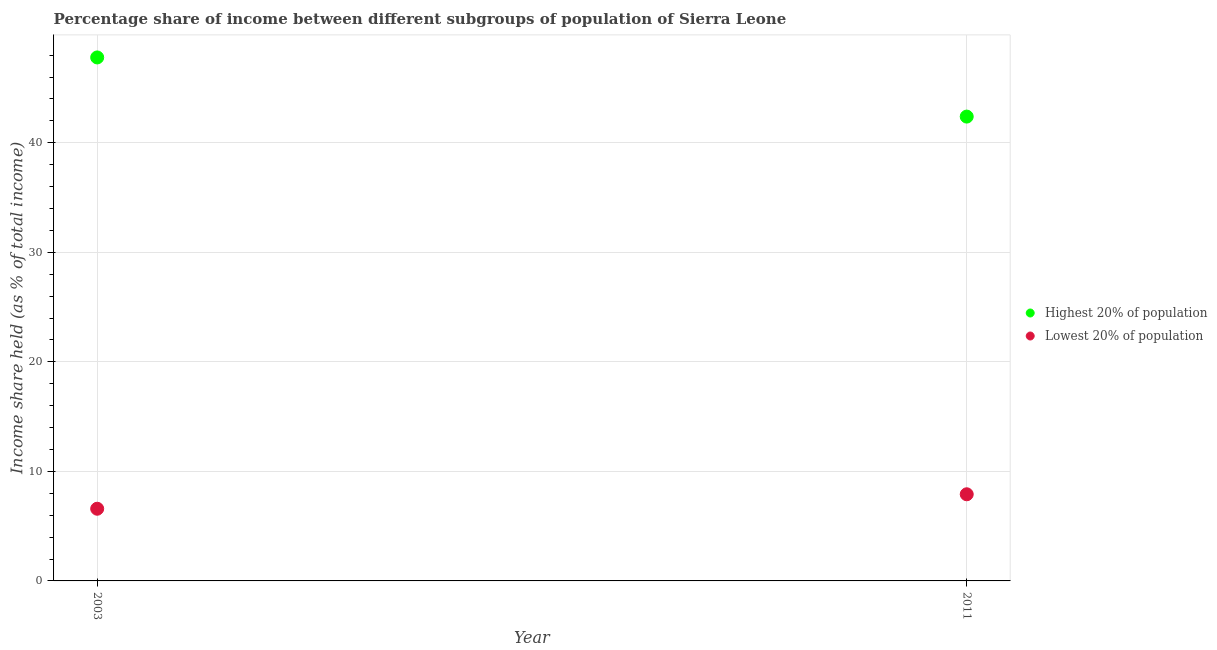Is the number of dotlines equal to the number of legend labels?
Your response must be concise. Yes. What is the income share held by lowest 20% of the population in 2011?
Offer a very short reply. 7.91. Across all years, what is the maximum income share held by lowest 20% of the population?
Your answer should be very brief. 7.91. Across all years, what is the minimum income share held by lowest 20% of the population?
Provide a succinct answer. 6.59. In which year was the income share held by highest 20% of the population minimum?
Offer a terse response. 2011. What is the total income share held by highest 20% of the population in the graph?
Your answer should be compact. 90.18. What is the difference between the income share held by highest 20% of the population in 2003 and that in 2011?
Ensure brevity in your answer.  5.4. What is the difference between the income share held by lowest 20% of the population in 2011 and the income share held by highest 20% of the population in 2003?
Your answer should be very brief. -39.88. What is the average income share held by lowest 20% of the population per year?
Your response must be concise. 7.25. In the year 2011, what is the difference between the income share held by lowest 20% of the population and income share held by highest 20% of the population?
Make the answer very short. -34.48. What is the ratio of the income share held by highest 20% of the population in 2003 to that in 2011?
Give a very brief answer. 1.13. Does the income share held by highest 20% of the population monotonically increase over the years?
Your response must be concise. No. Is the income share held by lowest 20% of the population strictly greater than the income share held by highest 20% of the population over the years?
Give a very brief answer. No. How many dotlines are there?
Offer a terse response. 2. How many years are there in the graph?
Give a very brief answer. 2. Does the graph contain grids?
Provide a succinct answer. Yes. Where does the legend appear in the graph?
Offer a very short reply. Center right. How are the legend labels stacked?
Offer a terse response. Vertical. What is the title of the graph?
Provide a short and direct response. Percentage share of income between different subgroups of population of Sierra Leone. What is the label or title of the X-axis?
Your answer should be very brief. Year. What is the label or title of the Y-axis?
Offer a very short reply. Income share held (as % of total income). What is the Income share held (as % of total income) in Highest 20% of population in 2003?
Provide a short and direct response. 47.79. What is the Income share held (as % of total income) in Lowest 20% of population in 2003?
Offer a terse response. 6.59. What is the Income share held (as % of total income) of Highest 20% of population in 2011?
Make the answer very short. 42.39. What is the Income share held (as % of total income) of Lowest 20% of population in 2011?
Your response must be concise. 7.91. Across all years, what is the maximum Income share held (as % of total income) in Highest 20% of population?
Offer a very short reply. 47.79. Across all years, what is the maximum Income share held (as % of total income) of Lowest 20% of population?
Your answer should be very brief. 7.91. Across all years, what is the minimum Income share held (as % of total income) in Highest 20% of population?
Provide a succinct answer. 42.39. Across all years, what is the minimum Income share held (as % of total income) of Lowest 20% of population?
Your answer should be very brief. 6.59. What is the total Income share held (as % of total income) of Highest 20% of population in the graph?
Your response must be concise. 90.18. What is the difference between the Income share held (as % of total income) in Lowest 20% of population in 2003 and that in 2011?
Your answer should be compact. -1.32. What is the difference between the Income share held (as % of total income) in Highest 20% of population in 2003 and the Income share held (as % of total income) in Lowest 20% of population in 2011?
Ensure brevity in your answer.  39.88. What is the average Income share held (as % of total income) in Highest 20% of population per year?
Keep it short and to the point. 45.09. What is the average Income share held (as % of total income) of Lowest 20% of population per year?
Ensure brevity in your answer.  7.25. In the year 2003, what is the difference between the Income share held (as % of total income) in Highest 20% of population and Income share held (as % of total income) in Lowest 20% of population?
Provide a short and direct response. 41.2. In the year 2011, what is the difference between the Income share held (as % of total income) of Highest 20% of population and Income share held (as % of total income) of Lowest 20% of population?
Your response must be concise. 34.48. What is the ratio of the Income share held (as % of total income) in Highest 20% of population in 2003 to that in 2011?
Offer a very short reply. 1.13. What is the ratio of the Income share held (as % of total income) of Lowest 20% of population in 2003 to that in 2011?
Provide a short and direct response. 0.83. What is the difference between the highest and the second highest Income share held (as % of total income) in Highest 20% of population?
Your answer should be compact. 5.4. What is the difference between the highest and the second highest Income share held (as % of total income) in Lowest 20% of population?
Offer a terse response. 1.32. What is the difference between the highest and the lowest Income share held (as % of total income) of Lowest 20% of population?
Keep it short and to the point. 1.32. 